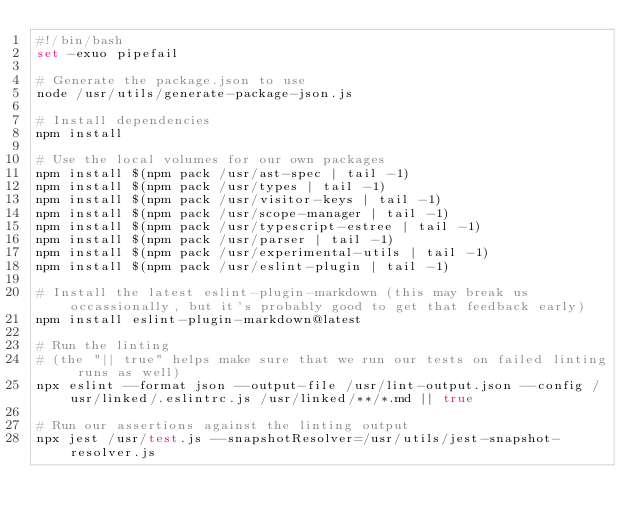Convert code to text. <code><loc_0><loc_0><loc_500><loc_500><_Bash_>#!/bin/bash
set -exuo pipefail

# Generate the package.json to use
node /usr/utils/generate-package-json.js

# Install dependencies
npm install

# Use the local volumes for our own packages
npm install $(npm pack /usr/ast-spec | tail -1)
npm install $(npm pack /usr/types | tail -1)
npm install $(npm pack /usr/visitor-keys | tail -1)
npm install $(npm pack /usr/scope-manager | tail -1)
npm install $(npm pack /usr/typescript-estree | tail -1)
npm install $(npm pack /usr/parser | tail -1)
npm install $(npm pack /usr/experimental-utils | tail -1)
npm install $(npm pack /usr/eslint-plugin | tail -1)

# Install the latest eslint-plugin-markdown (this may break us occassionally, but it's probably good to get that feedback early)
npm install eslint-plugin-markdown@latest

# Run the linting
# (the "|| true" helps make sure that we run our tests on failed linting runs as well)
npx eslint --format json --output-file /usr/lint-output.json --config /usr/linked/.eslintrc.js /usr/linked/**/*.md || true

# Run our assertions against the linting output
npx jest /usr/test.js --snapshotResolver=/usr/utils/jest-snapshot-resolver.js
</code> 